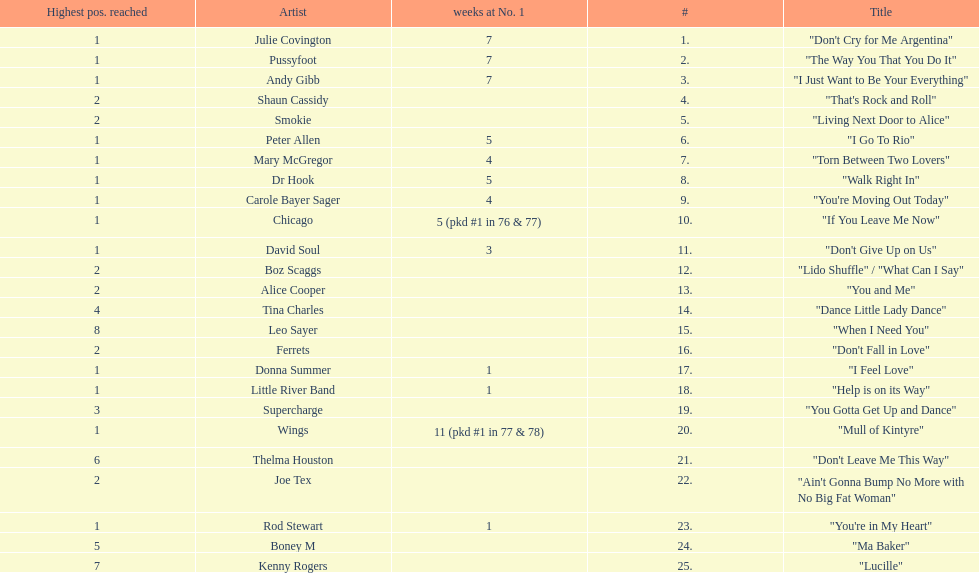What was the number of weeks that julie covington's single " don't cry for me argentinia," was at number 1 in 1977? 7. 